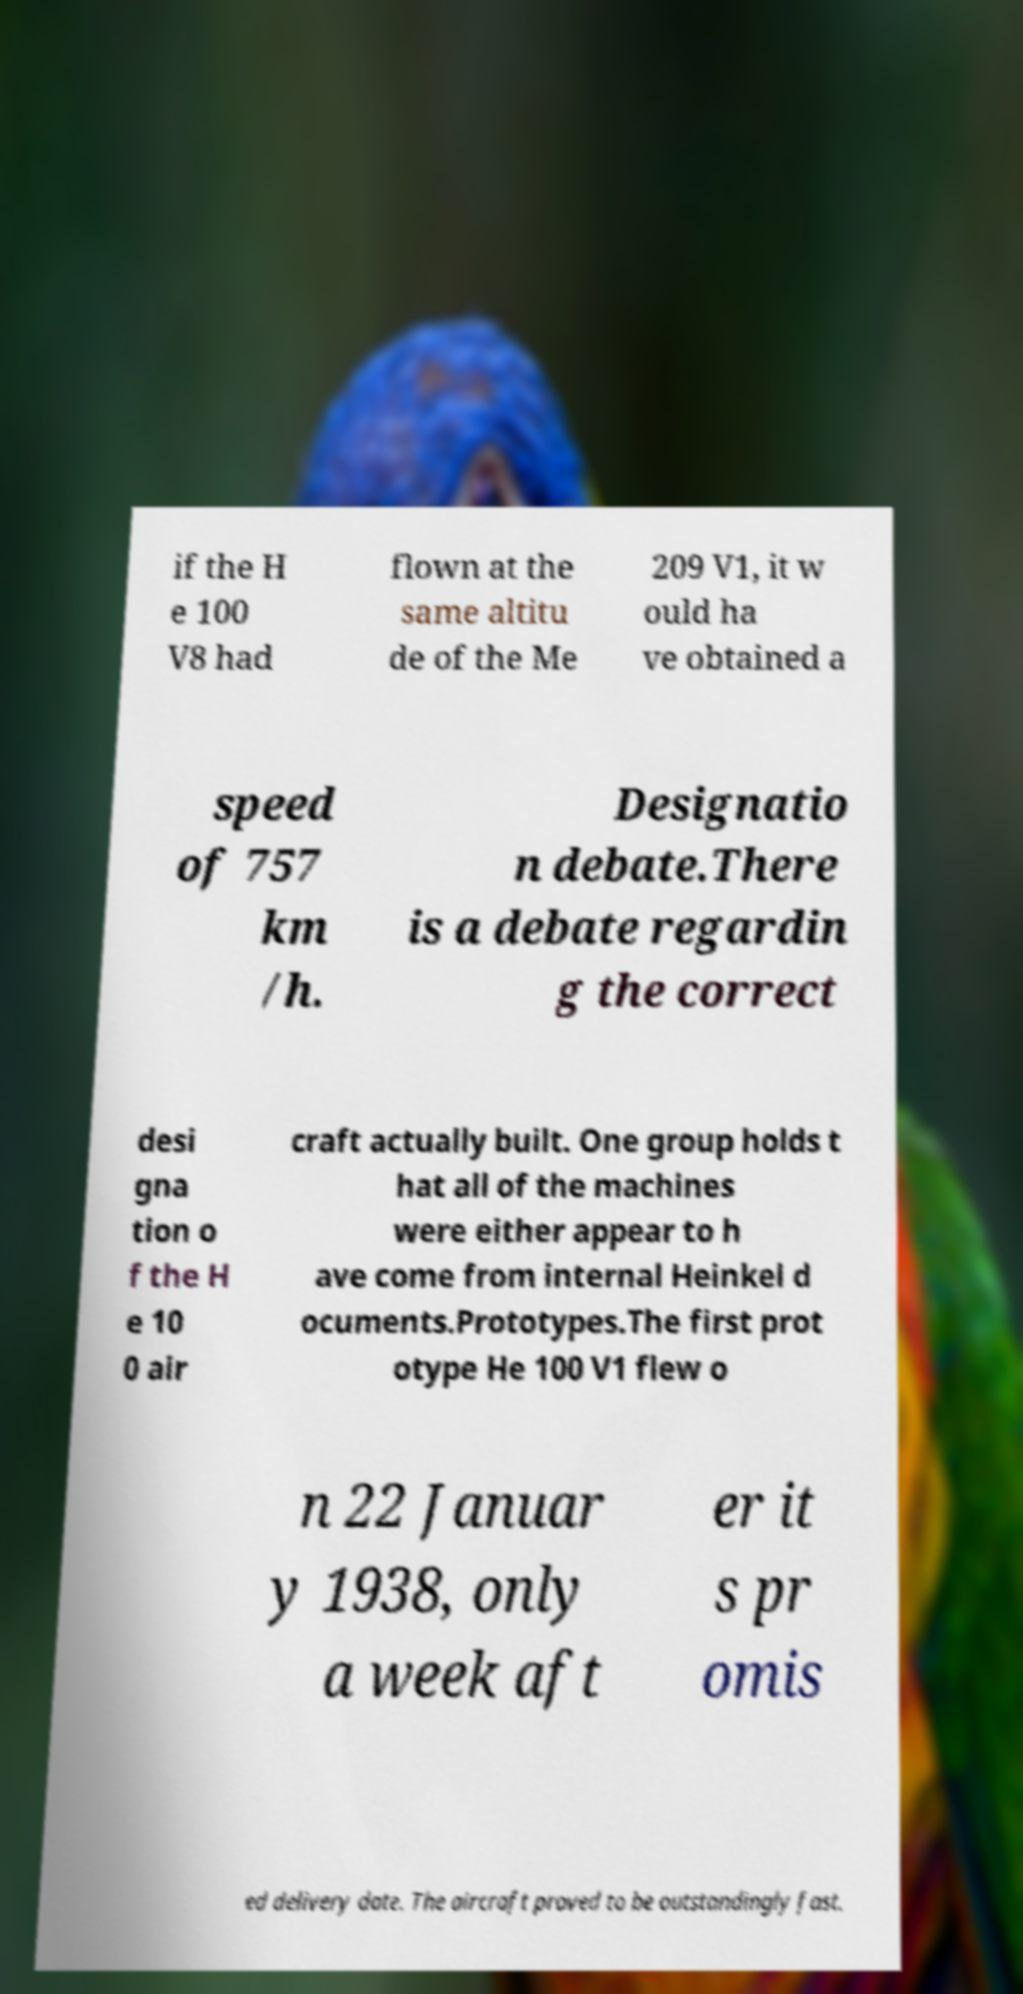For documentation purposes, I need the text within this image transcribed. Could you provide that? if the H e 100 V8 had flown at the same altitu de of the Me 209 V1, it w ould ha ve obtained a speed of 757 km /h. Designatio n debate.There is a debate regardin g the correct desi gna tion o f the H e 10 0 air craft actually built. One group holds t hat all of the machines were either appear to h ave come from internal Heinkel d ocuments.Prototypes.The first prot otype He 100 V1 flew o n 22 Januar y 1938, only a week aft er it s pr omis ed delivery date. The aircraft proved to be outstandingly fast. 